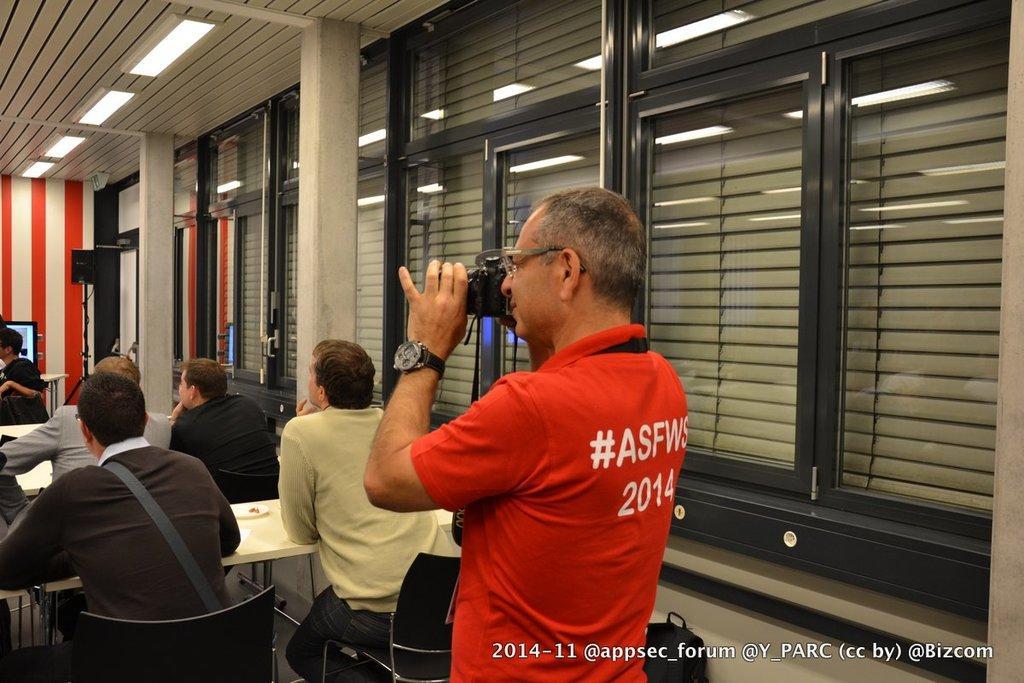In one or two sentences, can you explain what this image depicts? There is a person wearing red dress is standing and holding a camera in his hands and there are few people sitting in chairs in front of them. 